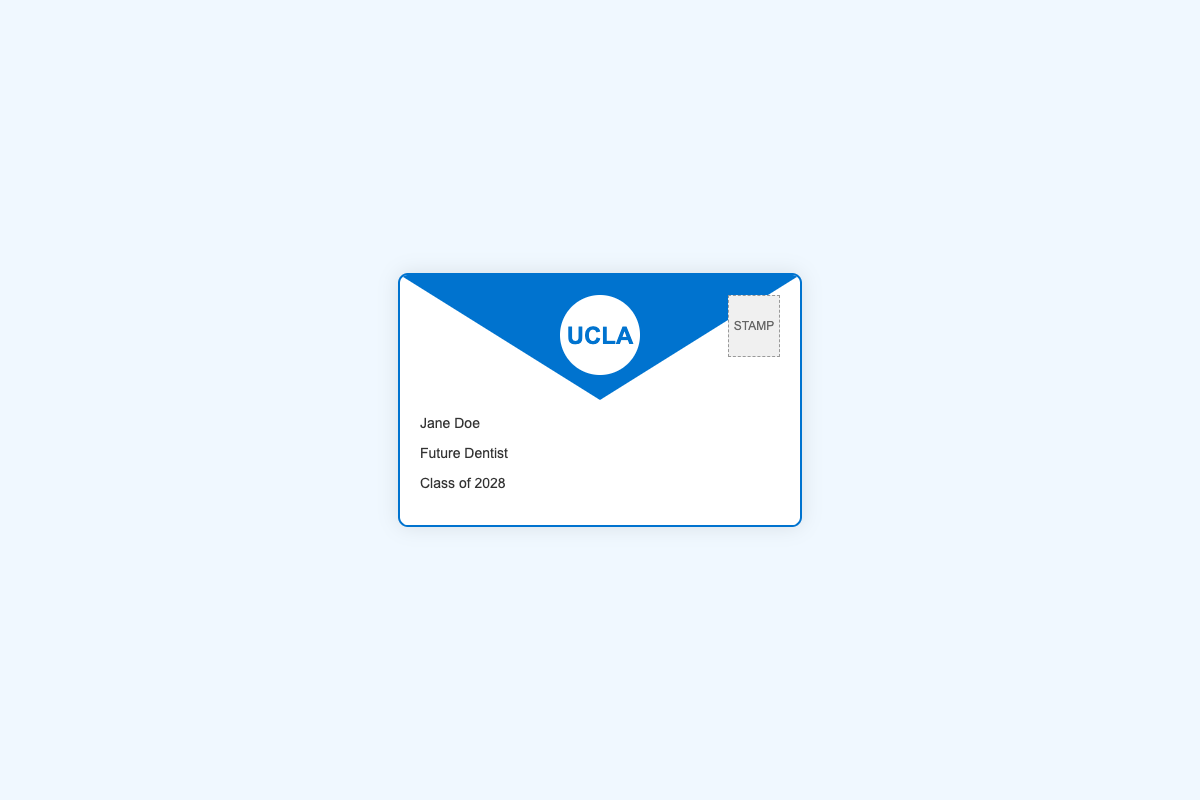what is the name of the student? The name of the student is displayed on the address section of the document as "Jane Doe."
Answer: Jane Doe what is the student's designation? The document shows the designation of the student, which is "Future Dentist."
Answer: Future Dentist what is the class year mentioned in the document? The class year indicated in the address section is "Class of 2028."
Answer: Class of 2028 what is the color of the envelope border? The border color of the envelope is specified as "#0073cf," which is a shade of blue.
Answer: blue what identifies the institution on the envelope? The institution is identified by a logo in the document with "UCLA" prominently displayed inside a circular shape.
Answer: UCLA how many corners does the envelope logo have? The envelope logo itself does not have corners but rather a circular shape, indicating a unique design feature.
Answer: 0 what type of document is this? The document represents an acceptance letter envelope for UCLA School of Dentistry.
Answer: acceptance letter what is the background color of the envelope? The background color of the envelope is shown to be white, contrasting with the blue border.
Answer: white 